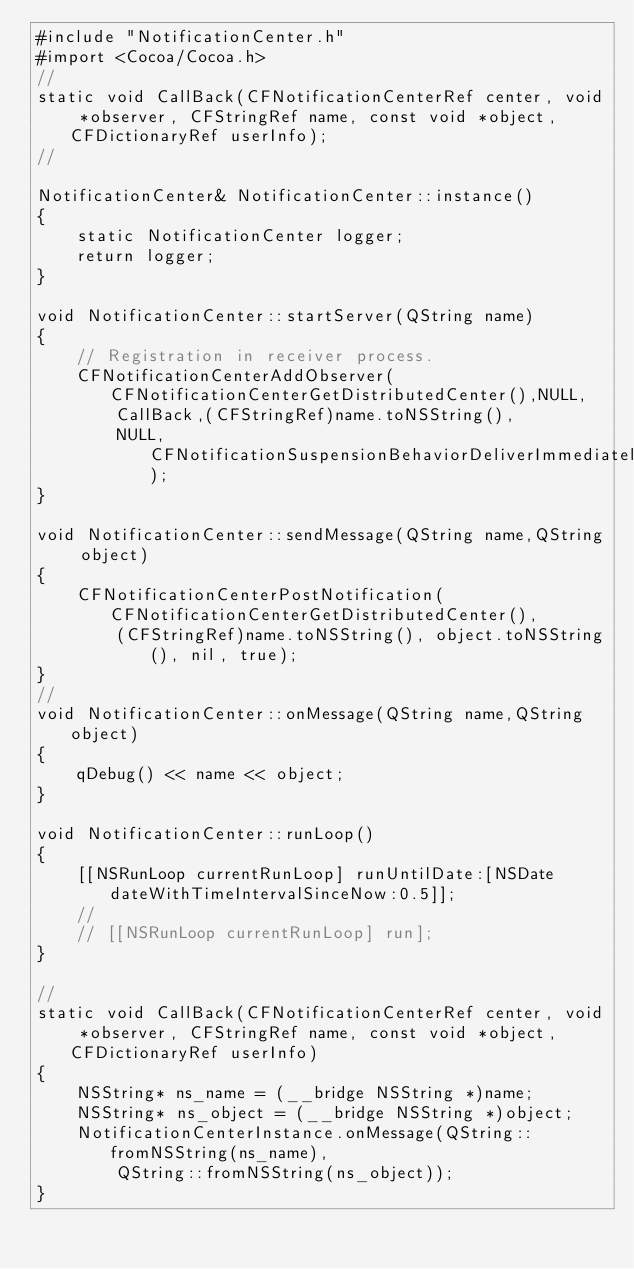Convert code to text. <code><loc_0><loc_0><loc_500><loc_500><_ObjectiveC_>#include "NotificationCenter.h"
#import <Cocoa/Cocoa.h>
//
static void CallBack(CFNotificationCenterRef center, void *observer, CFStringRef name, const void *object, CFDictionaryRef userInfo);
//

NotificationCenter& NotificationCenter::instance()
{
	static NotificationCenter logger;
	return logger;
}

void NotificationCenter::startServer(QString name)
{
    // Registration in receiver process.
    CFNotificationCenterAddObserver(CFNotificationCenterGetDistributedCenter(),NULL,
        CallBack,(CFStringRef)name.toNSString(),
        NULL,CFNotificationSuspensionBehaviorDeliverImmediately);
}

void NotificationCenter::sendMessage(QString name,QString object)
{  
    CFNotificationCenterPostNotification(CFNotificationCenterGetDistributedCenter(),
        (CFStringRef)name.toNSString(), object.toNSString(), nil, true);
}
//
void NotificationCenter::onMessage(QString name,QString object)
{
	qDebug() << name << object;
}

void NotificationCenter::runLoop()
{
	[[NSRunLoop currentRunLoop] runUntilDate:[NSDate dateWithTimeIntervalSinceNow:0.5]];
	//
	// [[NSRunLoop currentRunLoop] run];
}

//
static void CallBack(CFNotificationCenterRef center, void *observer, CFStringRef name, const void *object, CFDictionaryRef userInfo) 
{
	NSString* ns_name = (__bridge NSString *)name;
	NSString* ns_object = (__bridge NSString *)object;
	NotificationCenterInstance.onMessage(QString::fromNSString(ns_name), 
		QString::fromNSString(ns_object));
}
</code> 